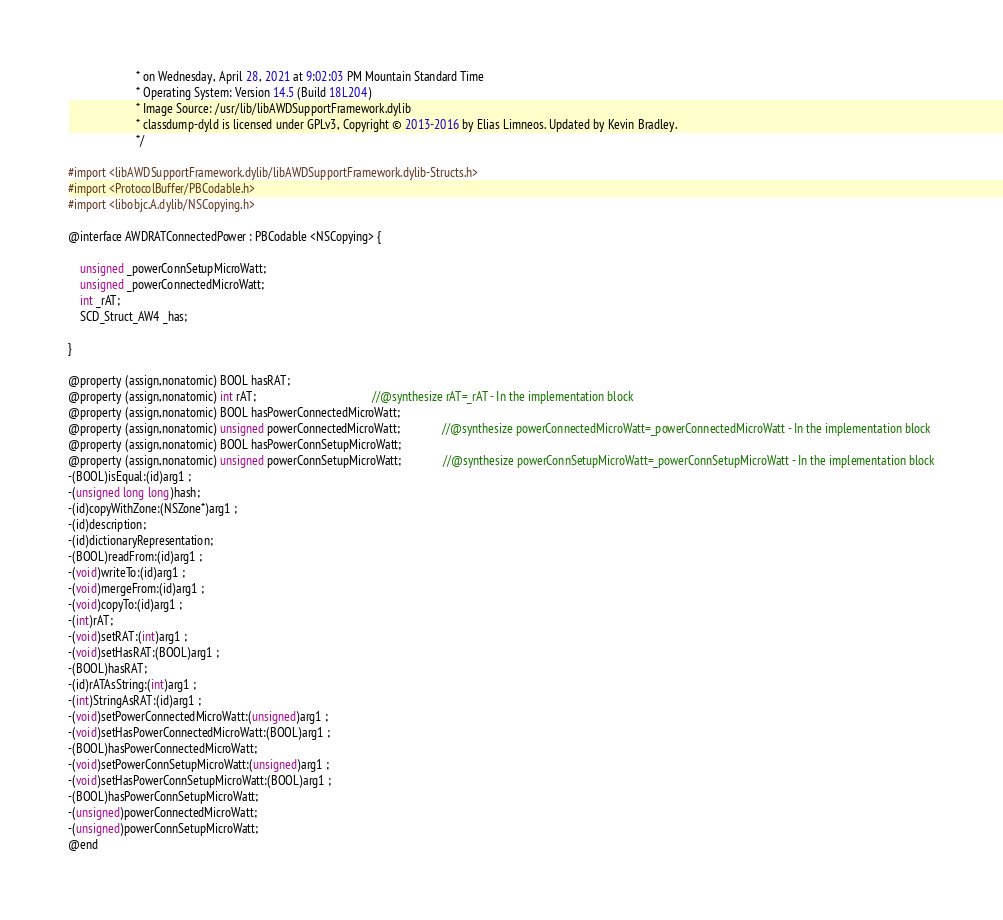<code> <loc_0><loc_0><loc_500><loc_500><_C_>                       * on Wednesday, April 28, 2021 at 9:02:03 PM Mountain Standard Time
                       * Operating System: Version 14.5 (Build 18L204)
                       * Image Source: /usr/lib/libAWDSupportFramework.dylib
                       * classdump-dyld is licensed under GPLv3, Copyright © 2013-2016 by Elias Limneos. Updated by Kevin Bradley.
                       */

#import <libAWDSupportFramework.dylib/libAWDSupportFramework.dylib-Structs.h>
#import <ProtocolBuffer/PBCodable.h>
#import <libobjc.A.dylib/NSCopying.h>

@interface AWDRATConnectedPower : PBCodable <NSCopying> {

	unsigned _powerConnSetupMicroWatt;
	unsigned _powerConnectedMicroWatt;
	int _rAT;
	SCD_Struct_AW4 _has;

}

@property (assign,nonatomic) BOOL hasRAT; 
@property (assign,nonatomic) int rAT;                                       //@synthesize rAT=_rAT - In the implementation block
@property (assign,nonatomic) BOOL hasPowerConnectedMicroWatt; 
@property (assign,nonatomic) unsigned powerConnectedMicroWatt;              //@synthesize powerConnectedMicroWatt=_powerConnectedMicroWatt - In the implementation block
@property (assign,nonatomic) BOOL hasPowerConnSetupMicroWatt; 
@property (assign,nonatomic) unsigned powerConnSetupMicroWatt;              //@synthesize powerConnSetupMicroWatt=_powerConnSetupMicroWatt - In the implementation block
-(BOOL)isEqual:(id)arg1 ;
-(unsigned long long)hash;
-(id)copyWithZone:(NSZone*)arg1 ;
-(id)description;
-(id)dictionaryRepresentation;
-(BOOL)readFrom:(id)arg1 ;
-(void)writeTo:(id)arg1 ;
-(void)mergeFrom:(id)arg1 ;
-(void)copyTo:(id)arg1 ;
-(int)rAT;
-(void)setRAT:(int)arg1 ;
-(void)setHasRAT:(BOOL)arg1 ;
-(BOOL)hasRAT;
-(id)rATAsString:(int)arg1 ;
-(int)StringAsRAT:(id)arg1 ;
-(void)setPowerConnectedMicroWatt:(unsigned)arg1 ;
-(void)setHasPowerConnectedMicroWatt:(BOOL)arg1 ;
-(BOOL)hasPowerConnectedMicroWatt;
-(void)setPowerConnSetupMicroWatt:(unsigned)arg1 ;
-(void)setHasPowerConnSetupMicroWatt:(BOOL)arg1 ;
-(BOOL)hasPowerConnSetupMicroWatt;
-(unsigned)powerConnectedMicroWatt;
-(unsigned)powerConnSetupMicroWatt;
@end

</code> 